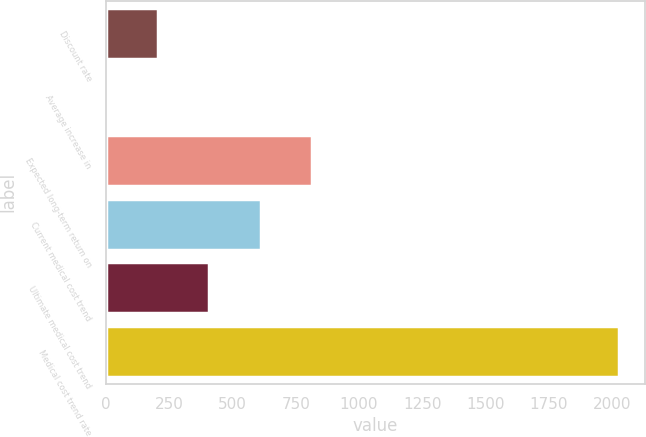Convert chart to OTSL. <chart><loc_0><loc_0><loc_500><loc_500><bar_chart><fcel>Discount rate<fcel>Average increase in<fcel>Expected long-term return on<fcel>Current medical cost trend<fcel>Ultimate medical cost trend<fcel>Medical cost trend rate<nl><fcel>205.6<fcel>3<fcel>813.4<fcel>610.8<fcel>408.2<fcel>2029<nl></chart> 